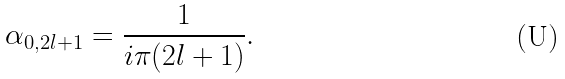<formula> <loc_0><loc_0><loc_500><loc_500>\alpha _ { 0 , 2 l + 1 } = \frac { 1 } { i \pi ( 2 l + 1 ) } .</formula> 